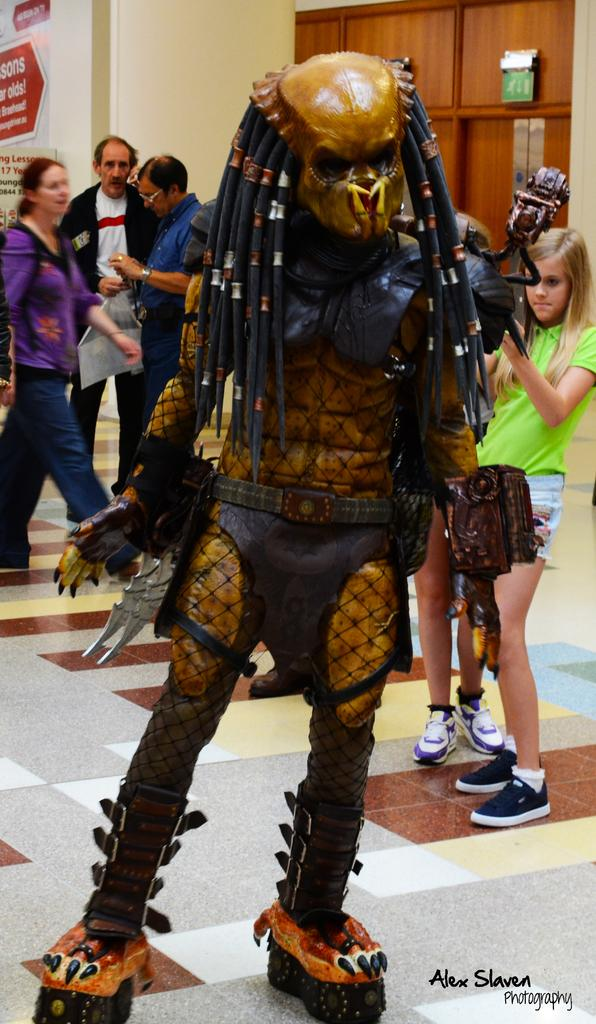What type of object resembling a person can be seen in the image? There is a toy resembling a person in the image. Are there any actual people in the image? Yes, there are people in the image. What can be seen at the left side of the image? There is an advertising board at the left side of the image. Can you see the coast in the image? There is no coast visible in the image. What type of spoon is being used by the people in the image? There is no spoon present in the image. 